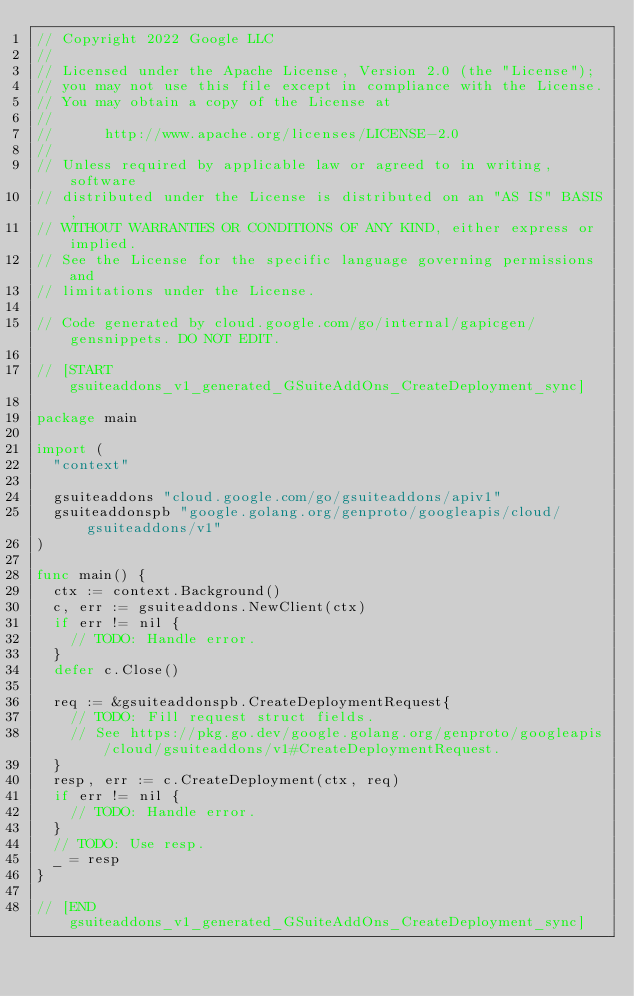<code> <loc_0><loc_0><loc_500><loc_500><_Go_>// Copyright 2022 Google LLC
//
// Licensed under the Apache License, Version 2.0 (the "License");
// you may not use this file except in compliance with the License.
// You may obtain a copy of the License at
//
//      http://www.apache.org/licenses/LICENSE-2.0
//
// Unless required by applicable law or agreed to in writing, software
// distributed under the License is distributed on an "AS IS" BASIS,
// WITHOUT WARRANTIES OR CONDITIONS OF ANY KIND, either express or implied.
// See the License for the specific language governing permissions and
// limitations under the License.

// Code generated by cloud.google.com/go/internal/gapicgen/gensnippets. DO NOT EDIT.

// [START gsuiteaddons_v1_generated_GSuiteAddOns_CreateDeployment_sync]

package main

import (
	"context"

	gsuiteaddons "cloud.google.com/go/gsuiteaddons/apiv1"
	gsuiteaddonspb "google.golang.org/genproto/googleapis/cloud/gsuiteaddons/v1"
)

func main() {
	ctx := context.Background()
	c, err := gsuiteaddons.NewClient(ctx)
	if err != nil {
		// TODO: Handle error.
	}
	defer c.Close()

	req := &gsuiteaddonspb.CreateDeploymentRequest{
		// TODO: Fill request struct fields.
		// See https://pkg.go.dev/google.golang.org/genproto/googleapis/cloud/gsuiteaddons/v1#CreateDeploymentRequest.
	}
	resp, err := c.CreateDeployment(ctx, req)
	if err != nil {
		// TODO: Handle error.
	}
	// TODO: Use resp.
	_ = resp
}

// [END gsuiteaddons_v1_generated_GSuiteAddOns_CreateDeployment_sync]
</code> 